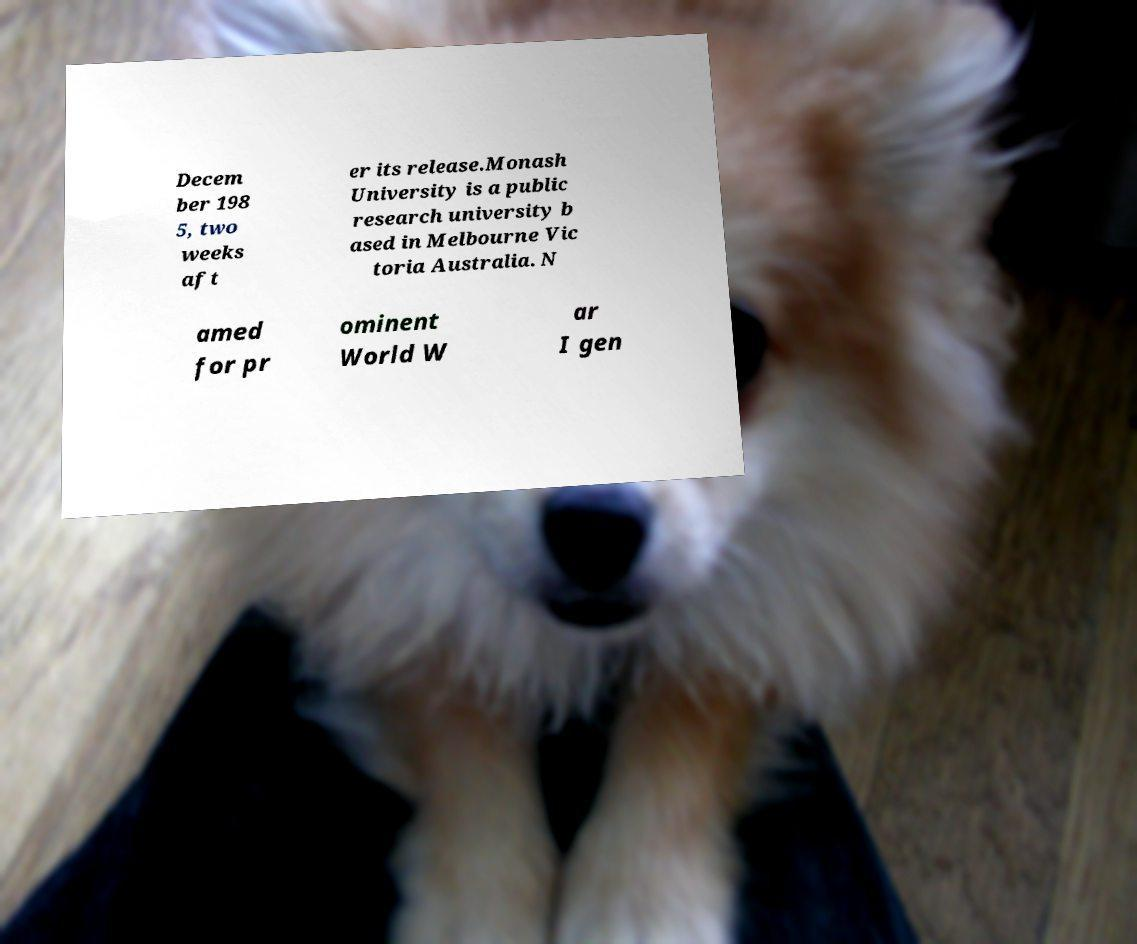Please identify and transcribe the text found in this image. Decem ber 198 5, two weeks aft er its release.Monash University is a public research university b ased in Melbourne Vic toria Australia. N amed for pr ominent World W ar I gen 